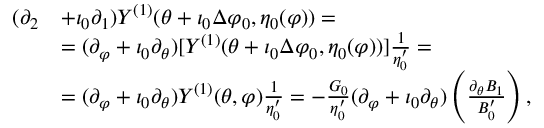<formula> <loc_0><loc_0><loc_500><loc_500>\begin{array} { r l } { ( \partial _ { 2 } } & { + \iota _ { 0 } \partial _ { 1 } ) Y ^ { ( 1 ) } ( \theta + \iota _ { 0 } \Delta \varphi _ { 0 } , \eta _ { 0 } ( \varphi ) ) = } \\ & { = ( \partial _ { \varphi } + \iota _ { 0 } \partial _ { \theta } ) [ Y ^ { ( 1 ) } ( \theta + \iota _ { 0 } \Delta \varphi _ { 0 } , \eta _ { 0 } ( \varphi ) ) ] \frac { 1 } { \eta _ { 0 } ^ { \prime } } = } \\ & { = ( \partial _ { \varphi } + \iota _ { 0 } \partial _ { \theta } ) Y ^ { ( 1 ) } ( \theta , \varphi ) \frac { 1 } { \eta _ { 0 } ^ { \prime } } = - \frac { G _ { 0 } } { \eta _ { 0 } ^ { \prime } } ( \partial _ { \varphi } + \iota _ { 0 } \partial _ { \theta } ) \left ( \frac { \partial _ { \theta } B _ { 1 } } { B _ { 0 } ^ { \prime } } \right ) , } \end{array}</formula> 